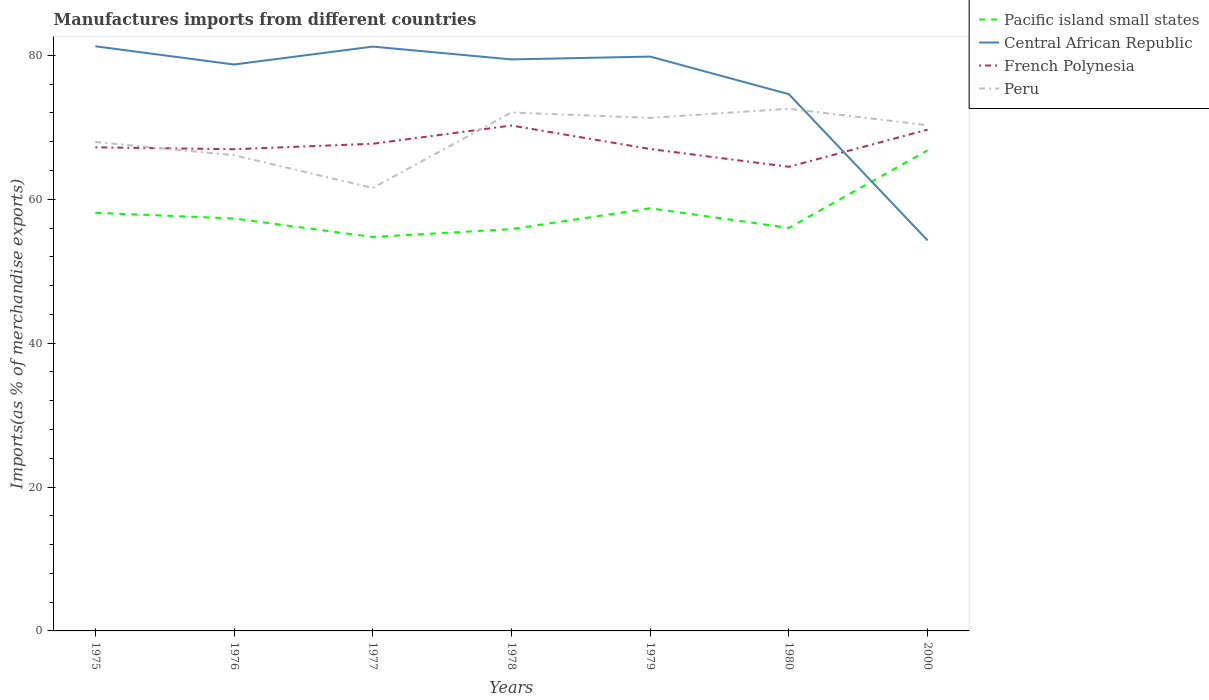Does the line corresponding to Peru intersect with the line corresponding to French Polynesia?
Give a very brief answer. Yes. Is the number of lines equal to the number of legend labels?
Ensure brevity in your answer.  Yes. Across all years, what is the maximum percentage of imports to different countries in Pacific island small states?
Make the answer very short. 54.76. In which year was the percentage of imports to different countries in Central African Republic maximum?
Offer a terse response. 2000. What is the total percentage of imports to different countries in French Polynesia in the graph?
Your answer should be compact. 5.74. What is the difference between the highest and the second highest percentage of imports to different countries in French Polynesia?
Make the answer very short. 5.74. Is the percentage of imports to different countries in Pacific island small states strictly greater than the percentage of imports to different countries in French Polynesia over the years?
Offer a very short reply. Yes. How many lines are there?
Offer a very short reply. 4. How many years are there in the graph?
Your answer should be compact. 7. Are the values on the major ticks of Y-axis written in scientific E-notation?
Ensure brevity in your answer.  No. Where does the legend appear in the graph?
Ensure brevity in your answer.  Top right. What is the title of the graph?
Ensure brevity in your answer.  Manufactures imports from different countries. What is the label or title of the Y-axis?
Provide a succinct answer. Imports(as % of merchandise exports). What is the Imports(as % of merchandise exports) in Pacific island small states in 1975?
Your answer should be very brief. 58.12. What is the Imports(as % of merchandise exports) in Central African Republic in 1975?
Make the answer very short. 81.27. What is the Imports(as % of merchandise exports) in French Polynesia in 1975?
Ensure brevity in your answer.  67.22. What is the Imports(as % of merchandise exports) of Peru in 1975?
Your answer should be very brief. 67.96. What is the Imports(as % of merchandise exports) of Pacific island small states in 1976?
Offer a very short reply. 57.33. What is the Imports(as % of merchandise exports) of Central African Republic in 1976?
Your response must be concise. 78.73. What is the Imports(as % of merchandise exports) in French Polynesia in 1976?
Your answer should be compact. 66.95. What is the Imports(as % of merchandise exports) in Peru in 1976?
Make the answer very short. 66.13. What is the Imports(as % of merchandise exports) in Pacific island small states in 1977?
Your answer should be compact. 54.76. What is the Imports(as % of merchandise exports) of Central African Republic in 1977?
Your answer should be compact. 81.22. What is the Imports(as % of merchandise exports) in French Polynesia in 1977?
Give a very brief answer. 67.72. What is the Imports(as % of merchandise exports) in Peru in 1977?
Ensure brevity in your answer.  61.57. What is the Imports(as % of merchandise exports) in Pacific island small states in 1978?
Offer a terse response. 55.85. What is the Imports(as % of merchandise exports) in Central African Republic in 1978?
Offer a terse response. 79.44. What is the Imports(as % of merchandise exports) of French Polynesia in 1978?
Your response must be concise. 70.25. What is the Imports(as % of merchandise exports) of Peru in 1978?
Ensure brevity in your answer.  72.06. What is the Imports(as % of merchandise exports) of Pacific island small states in 1979?
Make the answer very short. 58.75. What is the Imports(as % of merchandise exports) of Central African Republic in 1979?
Your answer should be compact. 79.83. What is the Imports(as % of merchandise exports) in French Polynesia in 1979?
Your answer should be very brief. 66.99. What is the Imports(as % of merchandise exports) of Peru in 1979?
Offer a very short reply. 71.31. What is the Imports(as % of merchandise exports) of Pacific island small states in 1980?
Provide a succinct answer. 56.02. What is the Imports(as % of merchandise exports) in Central African Republic in 1980?
Your response must be concise. 74.61. What is the Imports(as % of merchandise exports) in French Polynesia in 1980?
Offer a terse response. 64.51. What is the Imports(as % of merchandise exports) of Peru in 1980?
Provide a succinct answer. 72.58. What is the Imports(as % of merchandise exports) in Pacific island small states in 2000?
Provide a short and direct response. 66.81. What is the Imports(as % of merchandise exports) of Central African Republic in 2000?
Provide a short and direct response. 54.28. What is the Imports(as % of merchandise exports) in French Polynesia in 2000?
Provide a short and direct response. 69.68. What is the Imports(as % of merchandise exports) in Peru in 2000?
Provide a short and direct response. 70.29. Across all years, what is the maximum Imports(as % of merchandise exports) in Pacific island small states?
Provide a succinct answer. 66.81. Across all years, what is the maximum Imports(as % of merchandise exports) of Central African Republic?
Offer a very short reply. 81.27. Across all years, what is the maximum Imports(as % of merchandise exports) in French Polynesia?
Your answer should be compact. 70.25. Across all years, what is the maximum Imports(as % of merchandise exports) of Peru?
Your response must be concise. 72.58. Across all years, what is the minimum Imports(as % of merchandise exports) in Pacific island small states?
Ensure brevity in your answer.  54.76. Across all years, what is the minimum Imports(as % of merchandise exports) of Central African Republic?
Give a very brief answer. 54.28. Across all years, what is the minimum Imports(as % of merchandise exports) of French Polynesia?
Provide a succinct answer. 64.51. Across all years, what is the minimum Imports(as % of merchandise exports) in Peru?
Ensure brevity in your answer.  61.57. What is the total Imports(as % of merchandise exports) in Pacific island small states in the graph?
Make the answer very short. 407.64. What is the total Imports(as % of merchandise exports) of Central African Republic in the graph?
Provide a short and direct response. 529.38. What is the total Imports(as % of merchandise exports) in French Polynesia in the graph?
Offer a terse response. 473.32. What is the total Imports(as % of merchandise exports) of Peru in the graph?
Offer a terse response. 481.91. What is the difference between the Imports(as % of merchandise exports) of Pacific island small states in 1975 and that in 1976?
Give a very brief answer. 0.79. What is the difference between the Imports(as % of merchandise exports) of Central African Republic in 1975 and that in 1976?
Give a very brief answer. 2.53. What is the difference between the Imports(as % of merchandise exports) of French Polynesia in 1975 and that in 1976?
Keep it short and to the point. 0.27. What is the difference between the Imports(as % of merchandise exports) in Peru in 1975 and that in 1976?
Keep it short and to the point. 1.84. What is the difference between the Imports(as % of merchandise exports) in Pacific island small states in 1975 and that in 1977?
Keep it short and to the point. 3.36. What is the difference between the Imports(as % of merchandise exports) in Central African Republic in 1975 and that in 1977?
Offer a very short reply. 0.04. What is the difference between the Imports(as % of merchandise exports) of French Polynesia in 1975 and that in 1977?
Your answer should be compact. -0.49. What is the difference between the Imports(as % of merchandise exports) in Peru in 1975 and that in 1977?
Ensure brevity in your answer.  6.39. What is the difference between the Imports(as % of merchandise exports) of Pacific island small states in 1975 and that in 1978?
Provide a succinct answer. 2.27. What is the difference between the Imports(as % of merchandise exports) in Central African Republic in 1975 and that in 1978?
Your answer should be compact. 1.83. What is the difference between the Imports(as % of merchandise exports) of French Polynesia in 1975 and that in 1978?
Make the answer very short. -3.03. What is the difference between the Imports(as % of merchandise exports) of Peru in 1975 and that in 1978?
Ensure brevity in your answer.  -4.1. What is the difference between the Imports(as % of merchandise exports) of Pacific island small states in 1975 and that in 1979?
Your response must be concise. -0.63. What is the difference between the Imports(as % of merchandise exports) of Central African Republic in 1975 and that in 1979?
Ensure brevity in your answer.  1.43. What is the difference between the Imports(as % of merchandise exports) of French Polynesia in 1975 and that in 1979?
Offer a very short reply. 0.23. What is the difference between the Imports(as % of merchandise exports) of Peru in 1975 and that in 1979?
Provide a succinct answer. -3.35. What is the difference between the Imports(as % of merchandise exports) in Pacific island small states in 1975 and that in 1980?
Make the answer very short. 2.1. What is the difference between the Imports(as % of merchandise exports) of Central African Republic in 1975 and that in 1980?
Offer a very short reply. 6.66. What is the difference between the Imports(as % of merchandise exports) in French Polynesia in 1975 and that in 1980?
Ensure brevity in your answer.  2.71. What is the difference between the Imports(as % of merchandise exports) in Peru in 1975 and that in 1980?
Your answer should be very brief. -4.62. What is the difference between the Imports(as % of merchandise exports) in Pacific island small states in 1975 and that in 2000?
Offer a very short reply. -8.69. What is the difference between the Imports(as % of merchandise exports) in Central African Republic in 1975 and that in 2000?
Your answer should be compact. 26.98. What is the difference between the Imports(as % of merchandise exports) in French Polynesia in 1975 and that in 2000?
Keep it short and to the point. -2.46. What is the difference between the Imports(as % of merchandise exports) of Peru in 1975 and that in 2000?
Give a very brief answer. -2.33. What is the difference between the Imports(as % of merchandise exports) in Pacific island small states in 1976 and that in 1977?
Offer a terse response. 2.57. What is the difference between the Imports(as % of merchandise exports) in Central African Republic in 1976 and that in 1977?
Make the answer very short. -2.49. What is the difference between the Imports(as % of merchandise exports) of French Polynesia in 1976 and that in 1977?
Your answer should be compact. -0.76. What is the difference between the Imports(as % of merchandise exports) in Peru in 1976 and that in 1977?
Provide a succinct answer. 4.55. What is the difference between the Imports(as % of merchandise exports) in Pacific island small states in 1976 and that in 1978?
Your response must be concise. 1.48. What is the difference between the Imports(as % of merchandise exports) of Central African Republic in 1976 and that in 1978?
Make the answer very short. -0.71. What is the difference between the Imports(as % of merchandise exports) of French Polynesia in 1976 and that in 1978?
Give a very brief answer. -3.3. What is the difference between the Imports(as % of merchandise exports) of Peru in 1976 and that in 1978?
Your answer should be very brief. -5.93. What is the difference between the Imports(as % of merchandise exports) of Pacific island small states in 1976 and that in 1979?
Give a very brief answer. -1.42. What is the difference between the Imports(as % of merchandise exports) of Central African Republic in 1976 and that in 1979?
Your response must be concise. -1.1. What is the difference between the Imports(as % of merchandise exports) in French Polynesia in 1976 and that in 1979?
Your answer should be compact. -0.03. What is the difference between the Imports(as % of merchandise exports) of Peru in 1976 and that in 1979?
Your response must be concise. -5.19. What is the difference between the Imports(as % of merchandise exports) in Pacific island small states in 1976 and that in 1980?
Make the answer very short. 1.31. What is the difference between the Imports(as % of merchandise exports) of Central African Republic in 1976 and that in 1980?
Your response must be concise. 4.12. What is the difference between the Imports(as % of merchandise exports) of French Polynesia in 1976 and that in 1980?
Offer a terse response. 2.44. What is the difference between the Imports(as % of merchandise exports) in Peru in 1976 and that in 1980?
Offer a very short reply. -6.46. What is the difference between the Imports(as % of merchandise exports) in Pacific island small states in 1976 and that in 2000?
Offer a terse response. -9.48. What is the difference between the Imports(as % of merchandise exports) in Central African Republic in 1976 and that in 2000?
Offer a very short reply. 24.45. What is the difference between the Imports(as % of merchandise exports) in French Polynesia in 1976 and that in 2000?
Your answer should be compact. -2.72. What is the difference between the Imports(as % of merchandise exports) of Peru in 1976 and that in 2000?
Offer a very short reply. -4.17. What is the difference between the Imports(as % of merchandise exports) of Pacific island small states in 1977 and that in 1978?
Offer a very short reply. -1.09. What is the difference between the Imports(as % of merchandise exports) in Central African Republic in 1977 and that in 1978?
Keep it short and to the point. 1.78. What is the difference between the Imports(as % of merchandise exports) in French Polynesia in 1977 and that in 1978?
Give a very brief answer. -2.54. What is the difference between the Imports(as % of merchandise exports) of Peru in 1977 and that in 1978?
Your response must be concise. -10.49. What is the difference between the Imports(as % of merchandise exports) in Pacific island small states in 1977 and that in 1979?
Your response must be concise. -3.99. What is the difference between the Imports(as % of merchandise exports) in Central African Republic in 1977 and that in 1979?
Provide a succinct answer. 1.39. What is the difference between the Imports(as % of merchandise exports) of French Polynesia in 1977 and that in 1979?
Give a very brief answer. 0.73. What is the difference between the Imports(as % of merchandise exports) of Peru in 1977 and that in 1979?
Your response must be concise. -9.74. What is the difference between the Imports(as % of merchandise exports) in Pacific island small states in 1977 and that in 1980?
Your response must be concise. -1.26. What is the difference between the Imports(as % of merchandise exports) of Central African Republic in 1977 and that in 1980?
Your response must be concise. 6.61. What is the difference between the Imports(as % of merchandise exports) in French Polynesia in 1977 and that in 1980?
Your response must be concise. 3.2. What is the difference between the Imports(as % of merchandise exports) in Peru in 1977 and that in 1980?
Your response must be concise. -11.01. What is the difference between the Imports(as % of merchandise exports) in Pacific island small states in 1977 and that in 2000?
Offer a very short reply. -12.05. What is the difference between the Imports(as % of merchandise exports) in Central African Republic in 1977 and that in 2000?
Give a very brief answer. 26.94. What is the difference between the Imports(as % of merchandise exports) in French Polynesia in 1977 and that in 2000?
Offer a terse response. -1.96. What is the difference between the Imports(as % of merchandise exports) in Peru in 1977 and that in 2000?
Ensure brevity in your answer.  -8.72. What is the difference between the Imports(as % of merchandise exports) of Pacific island small states in 1978 and that in 1979?
Your answer should be very brief. -2.9. What is the difference between the Imports(as % of merchandise exports) of Central African Republic in 1978 and that in 1979?
Your answer should be very brief. -0.39. What is the difference between the Imports(as % of merchandise exports) in French Polynesia in 1978 and that in 1979?
Your answer should be very brief. 3.26. What is the difference between the Imports(as % of merchandise exports) in Peru in 1978 and that in 1979?
Offer a very short reply. 0.75. What is the difference between the Imports(as % of merchandise exports) of Pacific island small states in 1978 and that in 1980?
Offer a very short reply. -0.17. What is the difference between the Imports(as % of merchandise exports) of Central African Republic in 1978 and that in 1980?
Give a very brief answer. 4.83. What is the difference between the Imports(as % of merchandise exports) of French Polynesia in 1978 and that in 1980?
Offer a terse response. 5.74. What is the difference between the Imports(as % of merchandise exports) of Peru in 1978 and that in 1980?
Keep it short and to the point. -0.52. What is the difference between the Imports(as % of merchandise exports) in Pacific island small states in 1978 and that in 2000?
Provide a succinct answer. -10.96. What is the difference between the Imports(as % of merchandise exports) of Central African Republic in 1978 and that in 2000?
Ensure brevity in your answer.  25.16. What is the difference between the Imports(as % of merchandise exports) in French Polynesia in 1978 and that in 2000?
Offer a terse response. 0.57. What is the difference between the Imports(as % of merchandise exports) of Peru in 1978 and that in 2000?
Give a very brief answer. 1.77. What is the difference between the Imports(as % of merchandise exports) of Pacific island small states in 1979 and that in 1980?
Ensure brevity in your answer.  2.73. What is the difference between the Imports(as % of merchandise exports) of Central African Republic in 1979 and that in 1980?
Make the answer very short. 5.22. What is the difference between the Imports(as % of merchandise exports) in French Polynesia in 1979 and that in 1980?
Make the answer very short. 2.47. What is the difference between the Imports(as % of merchandise exports) in Peru in 1979 and that in 1980?
Make the answer very short. -1.27. What is the difference between the Imports(as % of merchandise exports) in Pacific island small states in 1979 and that in 2000?
Give a very brief answer. -8.06. What is the difference between the Imports(as % of merchandise exports) of Central African Republic in 1979 and that in 2000?
Offer a very short reply. 25.55. What is the difference between the Imports(as % of merchandise exports) in French Polynesia in 1979 and that in 2000?
Ensure brevity in your answer.  -2.69. What is the difference between the Imports(as % of merchandise exports) in Pacific island small states in 1980 and that in 2000?
Your answer should be compact. -10.79. What is the difference between the Imports(as % of merchandise exports) in Central African Republic in 1980 and that in 2000?
Your answer should be compact. 20.33. What is the difference between the Imports(as % of merchandise exports) of French Polynesia in 1980 and that in 2000?
Ensure brevity in your answer.  -5.16. What is the difference between the Imports(as % of merchandise exports) of Peru in 1980 and that in 2000?
Your answer should be compact. 2.29. What is the difference between the Imports(as % of merchandise exports) of Pacific island small states in 1975 and the Imports(as % of merchandise exports) of Central African Republic in 1976?
Make the answer very short. -20.61. What is the difference between the Imports(as % of merchandise exports) of Pacific island small states in 1975 and the Imports(as % of merchandise exports) of French Polynesia in 1976?
Make the answer very short. -8.84. What is the difference between the Imports(as % of merchandise exports) of Pacific island small states in 1975 and the Imports(as % of merchandise exports) of Peru in 1976?
Your response must be concise. -8.01. What is the difference between the Imports(as % of merchandise exports) in Central African Republic in 1975 and the Imports(as % of merchandise exports) in French Polynesia in 1976?
Keep it short and to the point. 14.31. What is the difference between the Imports(as % of merchandise exports) in Central African Republic in 1975 and the Imports(as % of merchandise exports) in Peru in 1976?
Offer a very short reply. 15.14. What is the difference between the Imports(as % of merchandise exports) of French Polynesia in 1975 and the Imports(as % of merchandise exports) of Peru in 1976?
Provide a succinct answer. 1.1. What is the difference between the Imports(as % of merchandise exports) in Pacific island small states in 1975 and the Imports(as % of merchandise exports) in Central African Republic in 1977?
Keep it short and to the point. -23.1. What is the difference between the Imports(as % of merchandise exports) in Pacific island small states in 1975 and the Imports(as % of merchandise exports) in French Polynesia in 1977?
Make the answer very short. -9.6. What is the difference between the Imports(as % of merchandise exports) in Pacific island small states in 1975 and the Imports(as % of merchandise exports) in Peru in 1977?
Your response must be concise. -3.45. What is the difference between the Imports(as % of merchandise exports) in Central African Republic in 1975 and the Imports(as % of merchandise exports) in French Polynesia in 1977?
Ensure brevity in your answer.  13.55. What is the difference between the Imports(as % of merchandise exports) in Central African Republic in 1975 and the Imports(as % of merchandise exports) in Peru in 1977?
Offer a terse response. 19.69. What is the difference between the Imports(as % of merchandise exports) of French Polynesia in 1975 and the Imports(as % of merchandise exports) of Peru in 1977?
Make the answer very short. 5.65. What is the difference between the Imports(as % of merchandise exports) of Pacific island small states in 1975 and the Imports(as % of merchandise exports) of Central African Republic in 1978?
Provide a short and direct response. -21.32. What is the difference between the Imports(as % of merchandise exports) in Pacific island small states in 1975 and the Imports(as % of merchandise exports) in French Polynesia in 1978?
Provide a short and direct response. -12.13. What is the difference between the Imports(as % of merchandise exports) of Pacific island small states in 1975 and the Imports(as % of merchandise exports) of Peru in 1978?
Provide a succinct answer. -13.94. What is the difference between the Imports(as % of merchandise exports) in Central African Republic in 1975 and the Imports(as % of merchandise exports) in French Polynesia in 1978?
Make the answer very short. 11.01. What is the difference between the Imports(as % of merchandise exports) in Central African Republic in 1975 and the Imports(as % of merchandise exports) in Peru in 1978?
Your answer should be compact. 9.21. What is the difference between the Imports(as % of merchandise exports) in French Polynesia in 1975 and the Imports(as % of merchandise exports) in Peru in 1978?
Your response must be concise. -4.84. What is the difference between the Imports(as % of merchandise exports) of Pacific island small states in 1975 and the Imports(as % of merchandise exports) of Central African Republic in 1979?
Make the answer very short. -21.71. What is the difference between the Imports(as % of merchandise exports) in Pacific island small states in 1975 and the Imports(as % of merchandise exports) in French Polynesia in 1979?
Provide a succinct answer. -8.87. What is the difference between the Imports(as % of merchandise exports) of Pacific island small states in 1975 and the Imports(as % of merchandise exports) of Peru in 1979?
Offer a very short reply. -13.19. What is the difference between the Imports(as % of merchandise exports) in Central African Republic in 1975 and the Imports(as % of merchandise exports) in French Polynesia in 1979?
Provide a short and direct response. 14.28. What is the difference between the Imports(as % of merchandise exports) in Central African Republic in 1975 and the Imports(as % of merchandise exports) in Peru in 1979?
Offer a terse response. 9.95. What is the difference between the Imports(as % of merchandise exports) of French Polynesia in 1975 and the Imports(as % of merchandise exports) of Peru in 1979?
Offer a very short reply. -4.09. What is the difference between the Imports(as % of merchandise exports) of Pacific island small states in 1975 and the Imports(as % of merchandise exports) of Central African Republic in 1980?
Provide a succinct answer. -16.49. What is the difference between the Imports(as % of merchandise exports) in Pacific island small states in 1975 and the Imports(as % of merchandise exports) in French Polynesia in 1980?
Make the answer very short. -6.39. What is the difference between the Imports(as % of merchandise exports) in Pacific island small states in 1975 and the Imports(as % of merchandise exports) in Peru in 1980?
Provide a short and direct response. -14.47. What is the difference between the Imports(as % of merchandise exports) in Central African Republic in 1975 and the Imports(as % of merchandise exports) in French Polynesia in 1980?
Ensure brevity in your answer.  16.75. What is the difference between the Imports(as % of merchandise exports) in Central African Republic in 1975 and the Imports(as % of merchandise exports) in Peru in 1980?
Provide a short and direct response. 8.68. What is the difference between the Imports(as % of merchandise exports) of French Polynesia in 1975 and the Imports(as % of merchandise exports) of Peru in 1980?
Offer a terse response. -5.36. What is the difference between the Imports(as % of merchandise exports) of Pacific island small states in 1975 and the Imports(as % of merchandise exports) of Central African Republic in 2000?
Provide a short and direct response. 3.83. What is the difference between the Imports(as % of merchandise exports) of Pacific island small states in 1975 and the Imports(as % of merchandise exports) of French Polynesia in 2000?
Ensure brevity in your answer.  -11.56. What is the difference between the Imports(as % of merchandise exports) in Pacific island small states in 1975 and the Imports(as % of merchandise exports) in Peru in 2000?
Provide a short and direct response. -12.18. What is the difference between the Imports(as % of merchandise exports) in Central African Republic in 1975 and the Imports(as % of merchandise exports) in French Polynesia in 2000?
Offer a terse response. 11.59. What is the difference between the Imports(as % of merchandise exports) of Central African Republic in 1975 and the Imports(as % of merchandise exports) of Peru in 2000?
Provide a short and direct response. 10.97. What is the difference between the Imports(as % of merchandise exports) of French Polynesia in 1975 and the Imports(as % of merchandise exports) of Peru in 2000?
Your answer should be compact. -3.07. What is the difference between the Imports(as % of merchandise exports) in Pacific island small states in 1976 and the Imports(as % of merchandise exports) in Central African Republic in 1977?
Provide a succinct answer. -23.89. What is the difference between the Imports(as % of merchandise exports) in Pacific island small states in 1976 and the Imports(as % of merchandise exports) in French Polynesia in 1977?
Provide a short and direct response. -10.38. What is the difference between the Imports(as % of merchandise exports) in Pacific island small states in 1976 and the Imports(as % of merchandise exports) in Peru in 1977?
Provide a succinct answer. -4.24. What is the difference between the Imports(as % of merchandise exports) of Central African Republic in 1976 and the Imports(as % of merchandise exports) of French Polynesia in 1977?
Ensure brevity in your answer.  11.02. What is the difference between the Imports(as % of merchandise exports) of Central African Republic in 1976 and the Imports(as % of merchandise exports) of Peru in 1977?
Give a very brief answer. 17.16. What is the difference between the Imports(as % of merchandise exports) of French Polynesia in 1976 and the Imports(as % of merchandise exports) of Peru in 1977?
Your answer should be compact. 5.38. What is the difference between the Imports(as % of merchandise exports) in Pacific island small states in 1976 and the Imports(as % of merchandise exports) in Central African Republic in 1978?
Offer a terse response. -22.11. What is the difference between the Imports(as % of merchandise exports) in Pacific island small states in 1976 and the Imports(as % of merchandise exports) in French Polynesia in 1978?
Offer a very short reply. -12.92. What is the difference between the Imports(as % of merchandise exports) of Pacific island small states in 1976 and the Imports(as % of merchandise exports) of Peru in 1978?
Give a very brief answer. -14.73. What is the difference between the Imports(as % of merchandise exports) of Central African Republic in 1976 and the Imports(as % of merchandise exports) of French Polynesia in 1978?
Make the answer very short. 8.48. What is the difference between the Imports(as % of merchandise exports) of Central African Republic in 1976 and the Imports(as % of merchandise exports) of Peru in 1978?
Your answer should be compact. 6.67. What is the difference between the Imports(as % of merchandise exports) of French Polynesia in 1976 and the Imports(as % of merchandise exports) of Peru in 1978?
Provide a short and direct response. -5.1. What is the difference between the Imports(as % of merchandise exports) of Pacific island small states in 1976 and the Imports(as % of merchandise exports) of Central African Republic in 1979?
Ensure brevity in your answer.  -22.5. What is the difference between the Imports(as % of merchandise exports) of Pacific island small states in 1976 and the Imports(as % of merchandise exports) of French Polynesia in 1979?
Provide a short and direct response. -9.66. What is the difference between the Imports(as % of merchandise exports) in Pacific island small states in 1976 and the Imports(as % of merchandise exports) in Peru in 1979?
Keep it short and to the point. -13.98. What is the difference between the Imports(as % of merchandise exports) in Central African Republic in 1976 and the Imports(as % of merchandise exports) in French Polynesia in 1979?
Give a very brief answer. 11.74. What is the difference between the Imports(as % of merchandise exports) in Central African Republic in 1976 and the Imports(as % of merchandise exports) in Peru in 1979?
Ensure brevity in your answer.  7.42. What is the difference between the Imports(as % of merchandise exports) in French Polynesia in 1976 and the Imports(as % of merchandise exports) in Peru in 1979?
Give a very brief answer. -4.36. What is the difference between the Imports(as % of merchandise exports) in Pacific island small states in 1976 and the Imports(as % of merchandise exports) in Central African Republic in 1980?
Make the answer very short. -17.28. What is the difference between the Imports(as % of merchandise exports) of Pacific island small states in 1976 and the Imports(as % of merchandise exports) of French Polynesia in 1980?
Your answer should be compact. -7.18. What is the difference between the Imports(as % of merchandise exports) in Pacific island small states in 1976 and the Imports(as % of merchandise exports) in Peru in 1980?
Provide a succinct answer. -15.25. What is the difference between the Imports(as % of merchandise exports) of Central African Republic in 1976 and the Imports(as % of merchandise exports) of French Polynesia in 1980?
Provide a short and direct response. 14.22. What is the difference between the Imports(as % of merchandise exports) of Central African Republic in 1976 and the Imports(as % of merchandise exports) of Peru in 1980?
Your answer should be compact. 6.15. What is the difference between the Imports(as % of merchandise exports) in French Polynesia in 1976 and the Imports(as % of merchandise exports) in Peru in 1980?
Keep it short and to the point. -5.63. What is the difference between the Imports(as % of merchandise exports) in Pacific island small states in 1976 and the Imports(as % of merchandise exports) in Central African Republic in 2000?
Offer a very short reply. 3.05. What is the difference between the Imports(as % of merchandise exports) of Pacific island small states in 1976 and the Imports(as % of merchandise exports) of French Polynesia in 2000?
Provide a short and direct response. -12.35. What is the difference between the Imports(as % of merchandise exports) in Pacific island small states in 1976 and the Imports(as % of merchandise exports) in Peru in 2000?
Your answer should be very brief. -12.96. What is the difference between the Imports(as % of merchandise exports) of Central African Republic in 1976 and the Imports(as % of merchandise exports) of French Polynesia in 2000?
Ensure brevity in your answer.  9.05. What is the difference between the Imports(as % of merchandise exports) in Central African Republic in 1976 and the Imports(as % of merchandise exports) in Peru in 2000?
Your answer should be very brief. 8.44. What is the difference between the Imports(as % of merchandise exports) of French Polynesia in 1976 and the Imports(as % of merchandise exports) of Peru in 2000?
Your answer should be compact. -3.34. What is the difference between the Imports(as % of merchandise exports) in Pacific island small states in 1977 and the Imports(as % of merchandise exports) in Central African Republic in 1978?
Offer a terse response. -24.68. What is the difference between the Imports(as % of merchandise exports) in Pacific island small states in 1977 and the Imports(as % of merchandise exports) in French Polynesia in 1978?
Make the answer very short. -15.49. What is the difference between the Imports(as % of merchandise exports) in Pacific island small states in 1977 and the Imports(as % of merchandise exports) in Peru in 1978?
Ensure brevity in your answer.  -17.3. What is the difference between the Imports(as % of merchandise exports) in Central African Republic in 1977 and the Imports(as % of merchandise exports) in French Polynesia in 1978?
Provide a short and direct response. 10.97. What is the difference between the Imports(as % of merchandise exports) of Central African Republic in 1977 and the Imports(as % of merchandise exports) of Peru in 1978?
Offer a very short reply. 9.16. What is the difference between the Imports(as % of merchandise exports) in French Polynesia in 1977 and the Imports(as % of merchandise exports) in Peru in 1978?
Your response must be concise. -4.34. What is the difference between the Imports(as % of merchandise exports) in Pacific island small states in 1977 and the Imports(as % of merchandise exports) in Central African Republic in 1979?
Your answer should be very brief. -25.07. What is the difference between the Imports(as % of merchandise exports) in Pacific island small states in 1977 and the Imports(as % of merchandise exports) in French Polynesia in 1979?
Provide a short and direct response. -12.23. What is the difference between the Imports(as % of merchandise exports) of Pacific island small states in 1977 and the Imports(as % of merchandise exports) of Peru in 1979?
Keep it short and to the point. -16.55. What is the difference between the Imports(as % of merchandise exports) in Central African Republic in 1977 and the Imports(as % of merchandise exports) in French Polynesia in 1979?
Provide a succinct answer. 14.23. What is the difference between the Imports(as % of merchandise exports) of Central African Republic in 1977 and the Imports(as % of merchandise exports) of Peru in 1979?
Provide a succinct answer. 9.91. What is the difference between the Imports(as % of merchandise exports) of French Polynesia in 1977 and the Imports(as % of merchandise exports) of Peru in 1979?
Offer a very short reply. -3.6. What is the difference between the Imports(as % of merchandise exports) of Pacific island small states in 1977 and the Imports(as % of merchandise exports) of Central African Republic in 1980?
Your answer should be compact. -19.85. What is the difference between the Imports(as % of merchandise exports) in Pacific island small states in 1977 and the Imports(as % of merchandise exports) in French Polynesia in 1980?
Your response must be concise. -9.75. What is the difference between the Imports(as % of merchandise exports) of Pacific island small states in 1977 and the Imports(as % of merchandise exports) of Peru in 1980?
Provide a succinct answer. -17.82. What is the difference between the Imports(as % of merchandise exports) in Central African Republic in 1977 and the Imports(as % of merchandise exports) in French Polynesia in 1980?
Make the answer very short. 16.71. What is the difference between the Imports(as % of merchandise exports) in Central African Republic in 1977 and the Imports(as % of merchandise exports) in Peru in 1980?
Your answer should be compact. 8.64. What is the difference between the Imports(as % of merchandise exports) in French Polynesia in 1977 and the Imports(as % of merchandise exports) in Peru in 1980?
Provide a short and direct response. -4.87. What is the difference between the Imports(as % of merchandise exports) in Pacific island small states in 1977 and the Imports(as % of merchandise exports) in Central African Republic in 2000?
Your answer should be very brief. 0.48. What is the difference between the Imports(as % of merchandise exports) of Pacific island small states in 1977 and the Imports(as % of merchandise exports) of French Polynesia in 2000?
Your response must be concise. -14.92. What is the difference between the Imports(as % of merchandise exports) in Pacific island small states in 1977 and the Imports(as % of merchandise exports) in Peru in 2000?
Offer a terse response. -15.53. What is the difference between the Imports(as % of merchandise exports) in Central African Republic in 1977 and the Imports(as % of merchandise exports) in French Polynesia in 2000?
Ensure brevity in your answer.  11.54. What is the difference between the Imports(as % of merchandise exports) of Central African Republic in 1977 and the Imports(as % of merchandise exports) of Peru in 2000?
Give a very brief answer. 10.93. What is the difference between the Imports(as % of merchandise exports) in French Polynesia in 1977 and the Imports(as % of merchandise exports) in Peru in 2000?
Offer a very short reply. -2.58. What is the difference between the Imports(as % of merchandise exports) of Pacific island small states in 1978 and the Imports(as % of merchandise exports) of Central African Republic in 1979?
Provide a succinct answer. -23.98. What is the difference between the Imports(as % of merchandise exports) in Pacific island small states in 1978 and the Imports(as % of merchandise exports) in French Polynesia in 1979?
Offer a terse response. -11.14. What is the difference between the Imports(as % of merchandise exports) in Pacific island small states in 1978 and the Imports(as % of merchandise exports) in Peru in 1979?
Give a very brief answer. -15.46. What is the difference between the Imports(as % of merchandise exports) of Central African Republic in 1978 and the Imports(as % of merchandise exports) of French Polynesia in 1979?
Your answer should be very brief. 12.45. What is the difference between the Imports(as % of merchandise exports) in Central African Republic in 1978 and the Imports(as % of merchandise exports) in Peru in 1979?
Keep it short and to the point. 8.13. What is the difference between the Imports(as % of merchandise exports) of French Polynesia in 1978 and the Imports(as % of merchandise exports) of Peru in 1979?
Provide a short and direct response. -1.06. What is the difference between the Imports(as % of merchandise exports) in Pacific island small states in 1978 and the Imports(as % of merchandise exports) in Central African Republic in 1980?
Offer a terse response. -18.76. What is the difference between the Imports(as % of merchandise exports) of Pacific island small states in 1978 and the Imports(as % of merchandise exports) of French Polynesia in 1980?
Your answer should be very brief. -8.66. What is the difference between the Imports(as % of merchandise exports) in Pacific island small states in 1978 and the Imports(as % of merchandise exports) in Peru in 1980?
Your answer should be very brief. -16.73. What is the difference between the Imports(as % of merchandise exports) of Central African Republic in 1978 and the Imports(as % of merchandise exports) of French Polynesia in 1980?
Offer a terse response. 14.93. What is the difference between the Imports(as % of merchandise exports) in Central African Republic in 1978 and the Imports(as % of merchandise exports) in Peru in 1980?
Provide a succinct answer. 6.86. What is the difference between the Imports(as % of merchandise exports) of French Polynesia in 1978 and the Imports(as % of merchandise exports) of Peru in 1980?
Keep it short and to the point. -2.33. What is the difference between the Imports(as % of merchandise exports) in Pacific island small states in 1978 and the Imports(as % of merchandise exports) in Central African Republic in 2000?
Offer a very short reply. 1.57. What is the difference between the Imports(as % of merchandise exports) in Pacific island small states in 1978 and the Imports(as % of merchandise exports) in French Polynesia in 2000?
Your answer should be compact. -13.83. What is the difference between the Imports(as % of merchandise exports) in Pacific island small states in 1978 and the Imports(as % of merchandise exports) in Peru in 2000?
Provide a short and direct response. -14.44. What is the difference between the Imports(as % of merchandise exports) in Central African Republic in 1978 and the Imports(as % of merchandise exports) in French Polynesia in 2000?
Provide a succinct answer. 9.76. What is the difference between the Imports(as % of merchandise exports) in Central African Republic in 1978 and the Imports(as % of merchandise exports) in Peru in 2000?
Offer a very short reply. 9.14. What is the difference between the Imports(as % of merchandise exports) in French Polynesia in 1978 and the Imports(as % of merchandise exports) in Peru in 2000?
Make the answer very short. -0.04. What is the difference between the Imports(as % of merchandise exports) of Pacific island small states in 1979 and the Imports(as % of merchandise exports) of Central African Republic in 1980?
Your response must be concise. -15.86. What is the difference between the Imports(as % of merchandise exports) in Pacific island small states in 1979 and the Imports(as % of merchandise exports) in French Polynesia in 1980?
Keep it short and to the point. -5.77. What is the difference between the Imports(as % of merchandise exports) of Pacific island small states in 1979 and the Imports(as % of merchandise exports) of Peru in 1980?
Your answer should be compact. -13.84. What is the difference between the Imports(as % of merchandise exports) in Central African Republic in 1979 and the Imports(as % of merchandise exports) in French Polynesia in 1980?
Ensure brevity in your answer.  15.32. What is the difference between the Imports(as % of merchandise exports) in Central African Republic in 1979 and the Imports(as % of merchandise exports) in Peru in 1980?
Your answer should be compact. 7.25. What is the difference between the Imports(as % of merchandise exports) of French Polynesia in 1979 and the Imports(as % of merchandise exports) of Peru in 1980?
Offer a very short reply. -5.6. What is the difference between the Imports(as % of merchandise exports) of Pacific island small states in 1979 and the Imports(as % of merchandise exports) of Central African Republic in 2000?
Offer a terse response. 4.46. What is the difference between the Imports(as % of merchandise exports) in Pacific island small states in 1979 and the Imports(as % of merchandise exports) in French Polynesia in 2000?
Your answer should be very brief. -10.93. What is the difference between the Imports(as % of merchandise exports) in Pacific island small states in 1979 and the Imports(as % of merchandise exports) in Peru in 2000?
Offer a terse response. -11.55. What is the difference between the Imports(as % of merchandise exports) in Central African Republic in 1979 and the Imports(as % of merchandise exports) in French Polynesia in 2000?
Make the answer very short. 10.16. What is the difference between the Imports(as % of merchandise exports) of Central African Republic in 1979 and the Imports(as % of merchandise exports) of Peru in 2000?
Offer a terse response. 9.54. What is the difference between the Imports(as % of merchandise exports) of French Polynesia in 1979 and the Imports(as % of merchandise exports) of Peru in 2000?
Keep it short and to the point. -3.31. What is the difference between the Imports(as % of merchandise exports) in Pacific island small states in 1980 and the Imports(as % of merchandise exports) in Central African Republic in 2000?
Provide a succinct answer. 1.74. What is the difference between the Imports(as % of merchandise exports) in Pacific island small states in 1980 and the Imports(as % of merchandise exports) in French Polynesia in 2000?
Give a very brief answer. -13.66. What is the difference between the Imports(as % of merchandise exports) in Pacific island small states in 1980 and the Imports(as % of merchandise exports) in Peru in 2000?
Ensure brevity in your answer.  -14.27. What is the difference between the Imports(as % of merchandise exports) of Central African Republic in 1980 and the Imports(as % of merchandise exports) of French Polynesia in 2000?
Provide a short and direct response. 4.93. What is the difference between the Imports(as % of merchandise exports) in Central African Republic in 1980 and the Imports(as % of merchandise exports) in Peru in 2000?
Offer a very short reply. 4.32. What is the difference between the Imports(as % of merchandise exports) in French Polynesia in 1980 and the Imports(as % of merchandise exports) in Peru in 2000?
Provide a succinct answer. -5.78. What is the average Imports(as % of merchandise exports) in Pacific island small states per year?
Offer a terse response. 58.23. What is the average Imports(as % of merchandise exports) in Central African Republic per year?
Offer a terse response. 75.63. What is the average Imports(as % of merchandise exports) in French Polynesia per year?
Keep it short and to the point. 67.62. What is the average Imports(as % of merchandise exports) in Peru per year?
Provide a short and direct response. 68.84. In the year 1975, what is the difference between the Imports(as % of merchandise exports) of Pacific island small states and Imports(as % of merchandise exports) of Central African Republic?
Provide a succinct answer. -23.15. In the year 1975, what is the difference between the Imports(as % of merchandise exports) of Pacific island small states and Imports(as % of merchandise exports) of French Polynesia?
Keep it short and to the point. -9.1. In the year 1975, what is the difference between the Imports(as % of merchandise exports) of Pacific island small states and Imports(as % of merchandise exports) of Peru?
Provide a succinct answer. -9.84. In the year 1975, what is the difference between the Imports(as % of merchandise exports) in Central African Republic and Imports(as % of merchandise exports) in French Polynesia?
Your answer should be very brief. 14.04. In the year 1975, what is the difference between the Imports(as % of merchandise exports) of Central African Republic and Imports(as % of merchandise exports) of Peru?
Offer a terse response. 13.3. In the year 1975, what is the difference between the Imports(as % of merchandise exports) of French Polynesia and Imports(as % of merchandise exports) of Peru?
Offer a terse response. -0.74. In the year 1976, what is the difference between the Imports(as % of merchandise exports) in Pacific island small states and Imports(as % of merchandise exports) in Central African Republic?
Ensure brevity in your answer.  -21.4. In the year 1976, what is the difference between the Imports(as % of merchandise exports) in Pacific island small states and Imports(as % of merchandise exports) in French Polynesia?
Your response must be concise. -9.62. In the year 1976, what is the difference between the Imports(as % of merchandise exports) of Pacific island small states and Imports(as % of merchandise exports) of Peru?
Your answer should be very brief. -8.79. In the year 1976, what is the difference between the Imports(as % of merchandise exports) in Central African Republic and Imports(as % of merchandise exports) in French Polynesia?
Keep it short and to the point. 11.78. In the year 1976, what is the difference between the Imports(as % of merchandise exports) of Central African Republic and Imports(as % of merchandise exports) of Peru?
Give a very brief answer. 12.61. In the year 1976, what is the difference between the Imports(as % of merchandise exports) of French Polynesia and Imports(as % of merchandise exports) of Peru?
Keep it short and to the point. 0.83. In the year 1977, what is the difference between the Imports(as % of merchandise exports) in Pacific island small states and Imports(as % of merchandise exports) in Central African Republic?
Your response must be concise. -26.46. In the year 1977, what is the difference between the Imports(as % of merchandise exports) in Pacific island small states and Imports(as % of merchandise exports) in French Polynesia?
Your answer should be compact. -12.95. In the year 1977, what is the difference between the Imports(as % of merchandise exports) of Pacific island small states and Imports(as % of merchandise exports) of Peru?
Make the answer very short. -6.81. In the year 1977, what is the difference between the Imports(as % of merchandise exports) of Central African Republic and Imports(as % of merchandise exports) of French Polynesia?
Your answer should be compact. 13.51. In the year 1977, what is the difference between the Imports(as % of merchandise exports) of Central African Republic and Imports(as % of merchandise exports) of Peru?
Your answer should be very brief. 19.65. In the year 1977, what is the difference between the Imports(as % of merchandise exports) in French Polynesia and Imports(as % of merchandise exports) in Peru?
Your answer should be compact. 6.14. In the year 1978, what is the difference between the Imports(as % of merchandise exports) in Pacific island small states and Imports(as % of merchandise exports) in Central African Republic?
Your answer should be very brief. -23.59. In the year 1978, what is the difference between the Imports(as % of merchandise exports) in Pacific island small states and Imports(as % of merchandise exports) in French Polynesia?
Offer a very short reply. -14.4. In the year 1978, what is the difference between the Imports(as % of merchandise exports) of Pacific island small states and Imports(as % of merchandise exports) of Peru?
Offer a terse response. -16.21. In the year 1978, what is the difference between the Imports(as % of merchandise exports) of Central African Republic and Imports(as % of merchandise exports) of French Polynesia?
Ensure brevity in your answer.  9.19. In the year 1978, what is the difference between the Imports(as % of merchandise exports) in Central African Republic and Imports(as % of merchandise exports) in Peru?
Ensure brevity in your answer.  7.38. In the year 1978, what is the difference between the Imports(as % of merchandise exports) of French Polynesia and Imports(as % of merchandise exports) of Peru?
Keep it short and to the point. -1.81. In the year 1979, what is the difference between the Imports(as % of merchandise exports) of Pacific island small states and Imports(as % of merchandise exports) of Central African Republic?
Offer a terse response. -21.08. In the year 1979, what is the difference between the Imports(as % of merchandise exports) in Pacific island small states and Imports(as % of merchandise exports) in French Polynesia?
Offer a terse response. -8.24. In the year 1979, what is the difference between the Imports(as % of merchandise exports) in Pacific island small states and Imports(as % of merchandise exports) in Peru?
Give a very brief answer. -12.56. In the year 1979, what is the difference between the Imports(as % of merchandise exports) of Central African Republic and Imports(as % of merchandise exports) of French Polynesia?
Provide a short and direct response. 12.85. In the year 1979, what is the difference between the Imports(as % of merchandise exports) of Central African Republic and Imports(as % of merchandise exports) of Peru?
Ensure brevity in your answer.  8.52. In the year 1979, what is the difference between the Imports(as % of merchandise exports) in French Polynesia and Imports(as % of merchandise exports) in Peru?
Offer a very short reply. -4.32. In the year 1980, what is the difference between the Imports(as % of merchandise exports) of Pacific island small states and Imports(as % of merchandise exports) of Central African Republic?
Your response must be concise. -18.59. In the year 1980, what is the difference between the Imports(as % of merchandise exports) in Pacific island small states and Imports(as % of merchandise exports) in French Polynesia?
Provide a short and direct response. -8.49. In the year 1980, what is the difference between the Imports(as % of merchandise exports) in Pacific island small states and Imports(as % of merchandise exports) in Peru?
Offer a terse response. -16.56. In the year 1980, what is the difference between the Imports(as % of merchandise exports) in Central African Republic and Imports(as % of merchandise exports) in French Polynesia?
Keep it short and to the point. 10.1. In the year 1980, what is the difference between the Imports(as % of merchandise exports) in Central African Republic and Imports(as % of merchandise exports) in Peru?
Make the answer very short. 2.03. In the year 1980, what is the difference between the Imports(as % of merchandise exports) of French Polynesia and Imports(as % of merchandise exports) of Peru?
Provide a short and direct response. -8.07. In the year 2000, what is the difference between the Imports(as % of merchandise exports) of Pacific island small states and Imports(as % of merchandise exports) of Central African Republic?
Ensure brevity in your answer.  12.52. In the year 2000, what is the difference between the Imports(as % of merchandise exports) of Pacific island small states and Imports(as % of merchandise exports) of French Polynesia?
Make the answer very short. -2.87. In the year 2000, what is the difference between the Imports(as % of merchandise exports) in Pacific island small states and Imports(as % of merchandise exports) in Peru?
Make the answer very short. -3.49. In the year 2000, what is the difference between the Imports(as % of merchandise exports) of Central African Republic and Imports(as % of merchandise exports) of French Polynesia?
Make the answer very short. -15.39. In the year 2000, what is the difference between the Imports(as % of merchandise exports) in Central African Republic and Imports(as % of merchandise exports) in Peru?
Keep it short and to the point. -16.01. In the year 2000, what is the difference between the Imports(as % of merchandise exports) of French Polynesia and Imports(as % of merchandise exports) of Peru?
Keep it short and to the point. -0.62. What is the ratio of the Imports(as % of merchandise exports) of Pacific island small states in 1975 to that in 1976?
Make the answer very short. 1.01. What is the ratio of the Imports(as % of merchandise exports) in Central African Republic in 1975 to that in 1976?
Ensure brevity in your answer.  1.03. What is the ratio of the Imports(as % of merchandise exports) of French Polynesia in 1975 to that in 1976?
Keep it short and to the point. 1. What is the ratio of the Imports(as % of merchandise exports) in Peru in 1975 to that in 1976?
Your response must be concise. 1.03. What is the ratio of the Imports(as % of merchandise exports) in Pacific island small states in 1975 to that in 1977?
Give a very brief answer. 1.06. What is the ratio of the Imports(as % of merchandise exports) of French Polynesia in 1975 to that in 1977?
Ensure brevity in your answer.  0.99. What is the ratio of the Imports(as % of merchandise exports) in Peru in 1975 to that in 1977?
Provide a succinct answer. 1.1. What is the ratio of the Imports(as % of merchandise exports) in Pacific island small states in 1975 to that in 1978?
Keep it short and to the point. 1.04. What is the ratio of the Imports(as % of merchandise exports) in French Polynesia in 1975 to that in 1978?
Provide a succinct answer. 0.96. What is the ratio of the Imports(as % of merchandise exports) in Peru in 1975 to that in 1978?
Make the answer very short. 0.94. What is the ratio of the Imports(as % of merchandise exports) in Pacific island small states in 1975 to that in 1979?
Offer a very short reply. 0.99. What is the ratio of the Imports(as % of merchandise exports) in Central African Republic in 1975 to that in 1979?
Your response must be concise. 1.02. What is the ratio of the Imports(as % of merchandise exports) of French Polynesia in 1975 to that in 1979?
Make the answer very short. 1. What is the ratio of the Imports(as % of merchandise exports) in Peru in 1975 to that in 1979?
Ensure brevity in your answer.  0.95. What is the ratio of the Imports(as % of merchandise exports) of Pacific island small states in 1975 to that in 1980?
Keep it short and to the point. 1.04. What is the ratio of the Imports(as % of merchandise exports) of Central African Republic in 1975 to that in 1980?
Give a very brief answer. 1.09. What is the ratio of the Imports(as % of merchandise exports) of French Polynesia in 1975 to that in 1980?
Provide a short and direct response. 1.04. What is the ratio of the Imports(as % of merchandise exports) of Peru in 1975 to that in 1980?
Give a very brief answer. 0.94. What is the ratio of the Imports(as % of merchandise exports) of Pacific island small states in 1975 to that in 2000?
Keep it short and to the point. 0.87. What is the ratio of the Imports(as % of merchandise exports) of Central African Republic in 1975 to that in 2000?
Offer a very short reply. 1.5. What is the ratio of the Imports(as % of merchandise exports) in French Polynesia in 1975 to that in 2000?
Offer a very short reply. 0.96. What is the ratio of the Imports(as % of merchandise exports) of Peru in 1975 to that in 2000?
Provide a succinct answer. 0.97. What is the ratio of the Imports(as % of merchandise exports) in Pacific island small states in 1976 to that in 1977?
Make the answer very short. 1.05. What is the ratio of the Imports(as % of merchandise exports) in Central African Republic in 1976 to that in 1977?
Make the answer very short. 0.97. What is the ratio of the Imports(as % of merchandise exports) in Peru in 1976 to that in 1977?
Your response must be concise. 1.07. What is the ratio of the Imports(as % of merchandise exports) in Pacific island small states in 1976 to that in 1978?
Provide a short and direct response. 1.03. What is the ratio of the Imports(as % of merchandise exports) of Central African Republic in 1976 to that in 1978?
Give a very brief answer. 0.99. What is the ratio of the Imports(as % of merchandise exports) of French Polynesia in 1976 to that in 1978?
Provide a succinct answer. 0.95. What is the ratio of the Imports(as % of merchandise exports) in Peru in 1976 to that in 1978?
Provide a succinct answer. 0.92. What is the ratio of the Imports(as % of merchandise exports) in Pacific island small states in 1976 to that in 1979?
Keep it short and to the point. 0.98. What is the ratio of the Imports(as % of merchandise exports) of Central African Republic in 1976 to that in 1979?
Provide a short and direct response. 0.99. What is the ratio of the Imports(as % of merchandise exports) in Peru in 1976 to that in 1979?
Your answer should be very brief. 0.93. What is the ratio of the Imports(as % of merchandise exports) of Pacific island small states in 1976 to that in 1980?
Keep it short and to the point. 1.02. What is the ratio of the Imports(as % of merchandise exports) in Central African Republic in 1976 to that in 1980?
Offer a very short reply. 1.06. What is the ratio of the Imports(as % of merchandise exports) of French Polynesia in 1976 to that in 1980?
Your answer should be very brief. 1.04. What is the ratio of the Imports(as % of merchandise exports) in Peru in 1976 to that in 1980?
Offer a very short reply. 0.91. What is the ratio of the Imports(as % of merchandise exports) of Pacific island small states in 1976 to that in 2000?
Give a very brief answer. 0.86. What is the ratio of the Imports(as % of merchandise exports) in Central African Republic in 1976 to that in 2000?
Provide a short and direct response. 1.45. What is the ratio of the Imports(as % of merchandise exports) in French Polynesia in 1976 to that in 2000?
Ensure brevity in your answer.  0.96. What is the ratio of the Imports(as % of merchandise exports) of Peru in 1976 to that in 2000?
Offer a terse response. 0.94. What is the ratio of the Imports(as % of merchandise exports) of Pacific island small states in 1977 to that in 1978?
Offer a terse response. 0.98. What is the ratio of the Imports(as % of merchandise exports) of Central African Republic in 1977 to that in 1978?
Give a very brief answer. 1.02. What is the ratio of the Imports(as % of merchandise exports) in French Polynesia in 1977 to that in 1978?
Your answer should be very brief. 0.96. What is the ratio of the Imports(as % of merchandise exports) in Peru in 1977 to that in 1978?
Offer a very short reply. 0.85. What is the ratio of the Imports(as % of merchandise exports) of Pacific island small states in 1977 to that in 1979?
Provide a succinct answer. 0.93. What is the ratio of the Imports(as % of merchandise exports) of Central African Republic in 1977 to that in 1979?
Offer a very short reply. 1.02. What is the ratio of the Imports(as % of merchandise exports) of French Polynesia in 1977 to that in 1979?
Your response must be concise. 1.01. What is the ratio of the Imports(as % of merchandise exports) in Peru in 1977 to that in 1979?
Keep it short and to the point. 0.86. What is the ratio of the Imports(as % of merchandise exports) of Pacific island small states in 1977 to that in 1980?
Ensure brevity in your answer.  0.98. What is the ratio of the Imports(as % of merchandise exports) of Central African Republic in 1977 to that in 1980?
Your response must be concise. 1.09. What is the ratio of the Imports(as % of merchandise exports) in French Polynesia in 1977 to that in 1980?
Keep it short and to the point. 1.05. What is the ratio of the Imports(as % of merchandise exports) in Peru in 1977 to that in 1980?
Your answer should be compact. 0.85. What is the ratio of the Imports(as % of merchandise exports) of Pacific island small states in 1977 to that in 2000?
Keep it short and to the point. 0.82. What is the ratio of the Imports(as % of merchandise exports) of Central African Republic in 1977 to that in 2000?
Ensure brevity in your answer.  1.5. What is the ratio of the Imports(as % of merchandise exports) in French Polynesia in 1977 to that in 2000?
Make the answer very short. 0.97. What is the ratio of the Imports(as % of merchandise exports) of Peru in 1977 to that in 2000?
Your response must be concise. 0.88. What is the ratio of the Imports(as % of merchandise exports) in Pacific island small states in 1978 to that in 1979?
Make the answer very short. 0.95. What is the ratio of the Imports(as % of merchandise exports) of Central African Republic in 1978 to that in 1979?
Provide a short and direct response. 1. What is the ratio of the Imports(as % of merchandise exports) of French Polynesia in 1978 to that in 1979?
Your answer should be very brief. 1.05. What is the ratio of the Imports(as % of merchandise exports) of Peru in 1978 to that in 1979?
Offer a terse response. 1.01. What is the ratio of the Imports(as % of merchandise exports) in Pacific island small states in 1978 to that in 1980?
Make the answer very short. 1. What is the ratio of the Imports(as % of merchandise exports) of Central African Republic in 1978 to that in 1980?
Your response must be concise. 1.06. What is the ratio of the Imports(as % of merchandise exports) in French Polynesia in 1978 to that in 1980?
Give a very brief answer. 1.09. What is the ratio of the Imports(as % of merchandise exports) in Pacific island small states in 1978 to that in 2000?
Your response must be concise. 0.84. What is the ratio of the Imports(as % of merchandise exports) in Central African Republic in 1978 to that in 2000?
Ensure brevity in your answer.  1.46. What is the ratio of the Imports(as % of merchandise exports) of French Polynesia in 1978 to that in 2000?
Ensure brevity in your answer.  1.01. What is the ratio of the Imports(as % of merchandise exports) in Peru in 1978 to that in 2000?
Give a very brief answer. 1.03. What is the ratio of the Imports(as % of merchandise exports) in Pacific island small states in 1979 to that in 1980?
Your answer should be compact. 1.05. What is the ratio of the Imports(as % of merchandise exports) of Central African Republic in 1979 to that in 1980?
Offer a terse response. 1.07. What is the ratio of the Imports(as % of merchandise exports) in French Polynesia in 1979 to that in 1980?
Give a very brief answer. 1.04. What is the ratio of the Imports(as % of merchandise exports) in Peru in 1979 to that in 1980?
Your response must be concise. 0.98. What is the ratio of the Imports(as % of merchandise exports) in Pacific island small states in 1979 to that in 2000?
Ensure brevity in your answer.  0.88. What is the ratio of the Imports(as % of merchandise exports) in Central African Republic in 1979 to that in 2000?
Provide a succinct answer. 1.47. What is the ratio of the Imports(as % of merchandise exports) of French Polynesia in 1979 to that in 2000?
Provide a succinct answer. 0.96. What is the ratio of the Imports(as % of merchandise exports) in Peru in 1979 to that in 2000?
Offer a very short reply. 1.01. What is the ratio of the Imports(as % of merchandise exports) in Pacific island small states in 1980 to that in 2000?
Your answer should be compact. 0.84. What is the ratio of the Imports(as % of merchandise exports) of Central African Republic in 1980 to that in 2000?
Give a very brief answer. 1.37. What is the ratio of the Imports(as % of merchandise exports) in French Polynesia in 1980 to that in 2000?
Give a very brief answer. 0.93. What is the ratio of the Imports(as % of merchandise exports) of Peru in 1980 to that in 2000?
Provide a succinct answer. 1.03. What is the difference between the highest and the second highest Imports(as % of merchandise exports) in Pacific island small states?
Offer a very short reply. 8.06. What is the difference between the highest and the second highest Imports(as % of merchandise exports) of Central African Republic?
Make the answer very short. 0.04. What is the difference between the highest and the second highest Imports(as % of merchandise exports) of French Polynesia?
Your response must be concise. 0.57. What is the difference between the highest and the second highest Imports(as % of merchandise exports) in Peru?
Ensure brevity in your answer.  0.52. What is the difference between the highest and the lowest Imports(as % of merchandise exports) of Pacific island small states?
Give a very brief answer. 12.05. What is the difference between the highest and the lowest Imports(as % of merchandise exports) in Central African Republic?
Offer a terse response. 26.98. What is the difference between the highest and the lowest Imports(as % of merchandise exports) in French Polynesia?
Ensure brevity in your answer.  5.74. What is the difference between the highest and the lowest Imports(as % of merchandise exports) in Peru?
Ensure brevity in your answer.  11.01. 